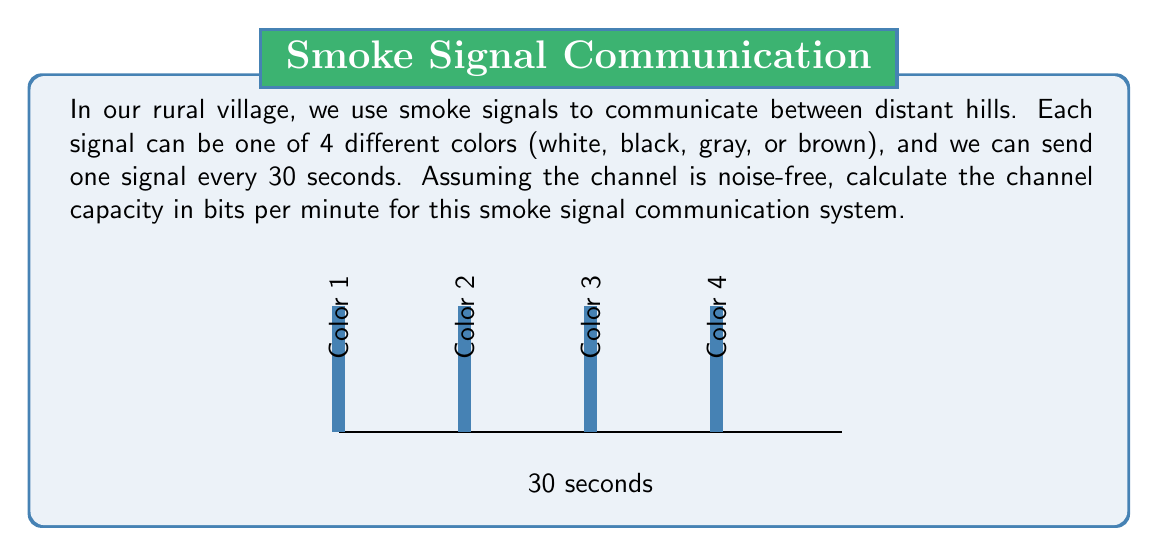Provide a solution to this math problem. To calculate the channel capacity, we'll use the formula:

$$C = R \log_2 M$$

Where:
$C$ is the channel capacity in bits per second
$R$ is the symbol rate (symbols per second)
$M$ is the number of possible symbols

Step 1: Calculate the symbol rate (R)
We can send one signal every 30 seconds, so:
$$R = \frac{1}{30} \text{ symbols/second}$$

Step 2: Determine the number of possible symbols (M)
We have 4 different colors, so:
$$M = 4$$

Step 3: Apply the channel capacity formula
$$C = \frac{1}{30} \log_2 4 \text{ bits/second}$$

Step 4: Simplify
$$C = \frac{1}{30} \cdot 2 = \frac{1}{15} \text{ bits/second}$$

Step 5: Convert to bits per minute
$$C = \frac{1}{15} \cdot 60 = 4 \text{ bits/minute}$$

Therefore, the channel capacity of our smoke signal system is 4 bits per minute.
Answer: 4 bits/minute 